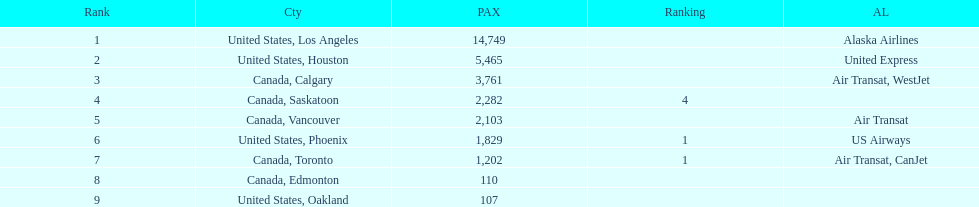How many airlines have a steady ranking? 4. 